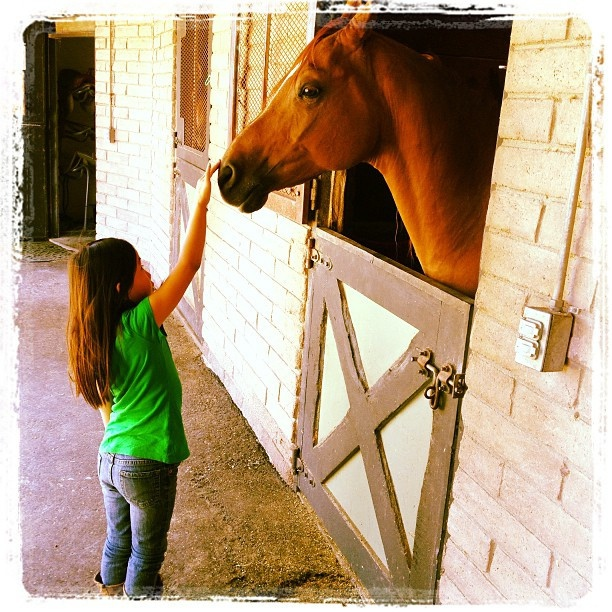Describe the objects in this image and their specific colors. I can see horse in white, black, maroon, and red tones and people in white, black, darkgreen, green, and lightgray tones in this image. 